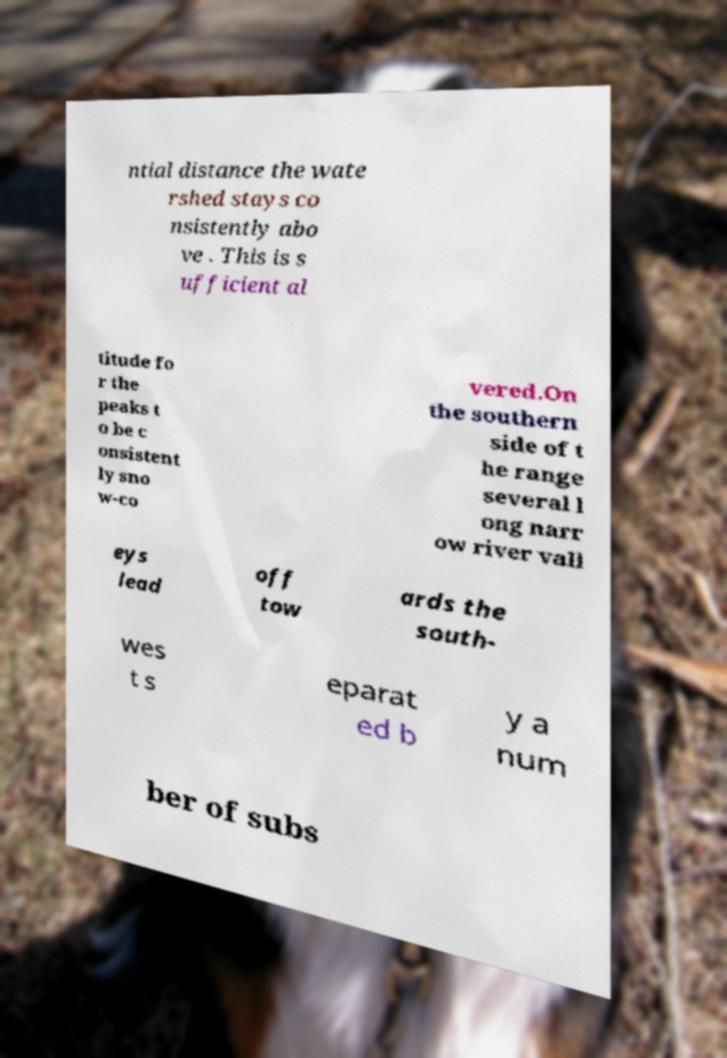Please identify and transcribe the text found in this image. ntial distance the wate rshed stays co nsistently abo ve . This is s ufficient al titude fo r the peaks t o be c onsistent ly sno w-co vered.On the southern side of t he range several l ong narr ow river vall eys lead off tow ards the south- wes t s eparat ed b y a num ber of subs 